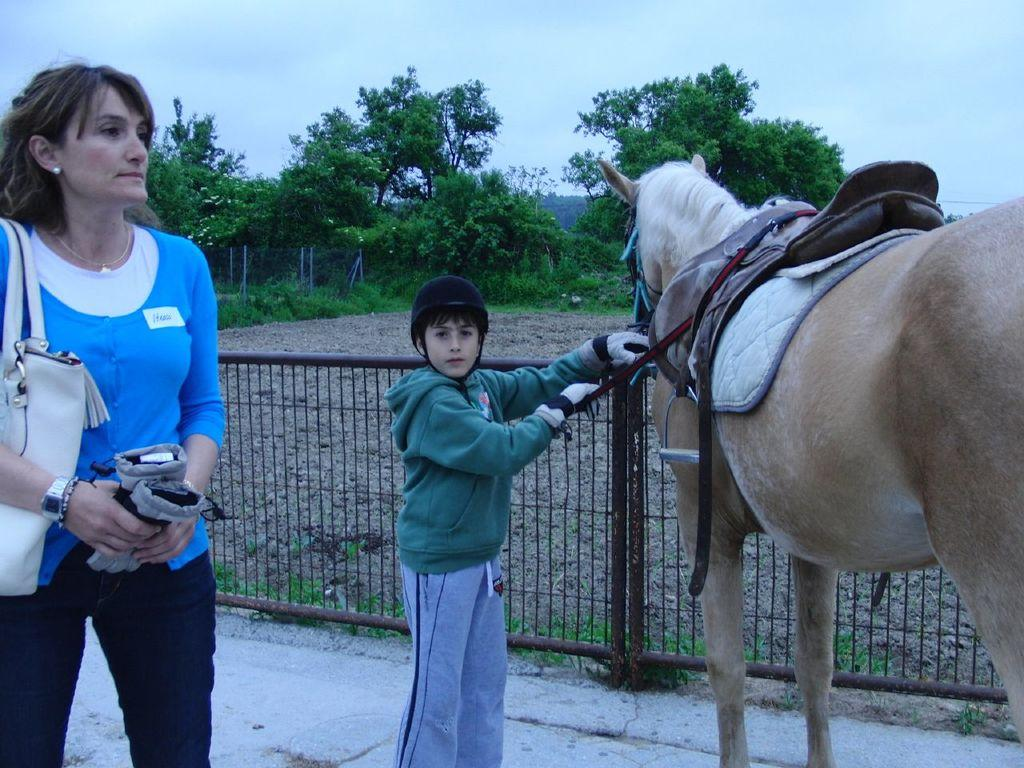Who is present on the left side of the image? There is a woman on the left side of the image. What is the woman holding in the image? The woman is holding a handbag. Who else is present in the image? There is a kid in the image. What is the kid holding in the image? The kid is holding a horse. What can be seen in the background of the image? There are trees visible in the background of the image. What color is the sand in the image? There is no sand present in the image. 